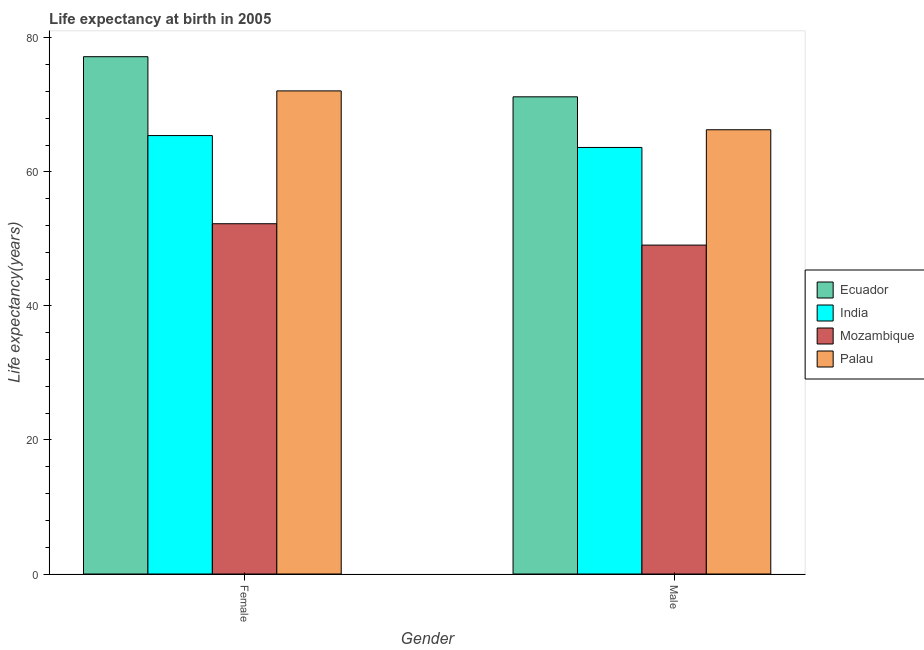Are the number of bars on each tick of the X-axis equal?
Make the answer very short. Yes. How many bars are there on the 2nd tick from the left?
Your answer should be very brief. 4. How many bars are there on the 1st tick from the right?
Your response must be concise. 4. What is the life expectancy(female) in India?
Provide a short and direct response. 65.43. Across all countries, what is the maximum life expectancy(female)?
Ensure brevity in your answer.  77.2. Across all countries, what is the minimum life expectancy(female)?
Make the answer very short. 52.27. In which country was the life expectancy(male) maximum?
Your response must be concise. Ecuador. In which country was the life expectancy(male) minimum?
Your response must be concise. Mozambique. What is the total life expectancy(female) in the graph?
Your response must be concise. 267.01. What is the difference between the life expectancy(female) in Palau and that in Ecuador?
Offer a very short reply. -5.11. What is the difference between the life expectancy(female) in Mozambique and the life expectancy(male) in Ecuador?
Your answer should be very brief. -18.94. What is the average life expectancy(male) per country?
Keep it short and to the point. 62.57. What is the difference between the life expectancy(female) and life expectancy(male) in Ecuador?
Your answer should be compact. 5.99. In how many countries, is the life expectancy(male) greater than 28 years?
Ensure brevity in your answer.  4. What is the ratio of the life expectancy(female) in Ecuador to that in Palau?
Ensure brevity in your answer.  1.07. Is the life expectancy(female) in Palau less than that in Ecuador?
Offer a very short reply. Yes. In how many countries, is the life expectancy(male) greater than the average life expectancy(male) taken over all countries?
Provide a succinct answer. 3. What does the 3rd bar from the left in Male represents?
Give a very brief answer. Mozambique. What does the 2nd bar from the right in Male represents?
Make the answer very short. Mozambique. How many bars are there?
Provide a succinct answer. 8. Are the values on the major ticks of Y-axis written in scientific E-notation?
Give a very brief answer. No. Does the graph contain grids?
Give a very brief answer. No. Where does the legend appear in the graph?
Your answer should be very brief. Center right. How are the legend labels stacked?
Give a very brief answer. Vertical. What is the title of the graph?
Your answer should be very brief. Life expectancy at birth in 2005. What is the label or title of the Y-axis?
Make the answer very short. Life expectancy(years). What is the Life expectancy(years) in Ecuador in Female?
Keep it short and to the point. 77.2. What is the Life expectancy(years) in India in Female?
Offer a very short reply. 65.43. What is the Life expectancy(years) of Mozambique in Female?
Your answer should be very brief. 52.27. What is the Life expectancy(years) of Palau in Female?
Your answer should be compact. 72.1. What is the Life expectancy(years) in Ecuador in Male?
Offer a terse response. 71.22. What is the Life expectancy(years) of India in Male?
Your response must be concise. 63.66. What is the Life expectancy(years) of Mozambique in Male?
Keep it short and to the point. 49.09. What is the Life expectancy(years) in Palau in Male?
Offer a terse response. 66.3. Across all Gender, what is the maximum Life expectancy(years) of Ecuador?
Offer a terse response. 77.2. Across all Gender, what is the maximum Life expectancy(years) in India?
Offer a very short reply. 65.43. Across all Gender, what is the maximum Life expectancy(years) of Mozambique?
Offer a very short reply. 52.27. Across all Gender, what is the maximum Life expectancy(years) of Palau?
Provide a succinct answer. 72.1. Across all Gender, what is the minimum Life expectancy(years) in Ecuador?
Give a very brief answer. 71.22. Across all Gender, what is the minimum Life expectancy(years) in India?
Ensure brevity in your answer.  63.66. Across all Gender, what is the minimum Life expectancy(years) of Mozambique?
Your response must be concise. 49.09. Across all Gender, what is the minimum Life expectancy(years) in Palau?
Provide a short and direct response. 66.3. What is the total Life expectancy(years) in Ecuador in the graph?
Keep it short and to the point. 148.42. What is the total Life expectancy(years) in India in the graph?
Offer a terse response. 129.09. What is the total Life expectancy(years) in Mozambique in the graph?
Give a very brief answer. 101.36. What is the total Life expectancy(years) in Palau in the graph?
Make the answer very short. 138.4. What is the difference between the Life expectancy(years) in Ecuador in Female and that in Male?
Offer a very short reply. 5.99. What is the difference between the Life expectancy(years) in India in Female and that in Male?
Provide a succinct answer. 1.77. What is the difference between the Life expectancy(years) of Mozambique in Female and that in Male?
Your answer should be very brief. 3.19. What is the difference between the Life expectancy(years) of Palau in Female and that in Male?
Your response must be concise. 5.8. What is the difference between the Life expectancy(years) of Ecuador in Female and the Life expectancy(years) of India in Male?
Give a very brief answer. 13.55. What is the difference between the Life expectancy(years) in Ecuador in Female and the Life expectancy(years) in Mozambique in Male?
Your answer should be very brief. 28.12. What is the difference between the Life expectancy(years) in Ecuador in Female and the Life expectancy(years) in Palau in Male?
Ensure brevity in your answer.  10.9. What is the difference between the Life expectancy(years) in India in Female and the Life expectancy(years) in Mozambique in Male?
Give a very brief answer. 16.35. What is the difference between the Life expectancy(years) of India in Female and the Life expectancy(years) of Palau in Male?
Ensure brevity in your answer.  -0.87. What is the difference between the Life expectancy(years) in Mozambique in Female and the Life expectancy(years) in Palau in Male?
Offer a terse response. -14.03. What is the average Life expectancy(years) of Ecuador per Gender?
Make the answer very short. 74.21. What is the average Life expectancy(years) of India per Gender?
Provide a succinct answer. 64.55. What is the average Life expectancy(years) of Mozambique per Gender?
Provide a succinct answer. 50.68. What is the average Life expectancy(years) of Palau per Gender?
Make the answer very short. 69.2. What is the difference between the Life expectancy(years) of Ecuador and Life expectancy(years) of India in Female?
Provide a succinct answer. 11.77. What is the difference between the Life expectancy(years) of Ecuador and Life expectancy(years) of Mozambique in Female?
Your answer should be compact. 24.93. What is the difference between the Life expectancy(years) of Ecuador and Life expectancy(years) of Palau in Female?
Offer a terse response. 5.11. What is the difference between the Life expectancy(years) in India and Life expectancy(years) in Mozambique in Female?
Your answer should be very brief. 13.16. What is the difference between the Life expectancy(years) in India and Life expectancy(years) in Palau in Female?
Your answer should be compact. -6.67. What is the difference between the Life expectancy(years) in Mozambique and Life expectancy(years) in Palau in Female?
Your answer should be very brief. -19.82. What is the difference between the Life expectancy(years) of Ecuador and Life expectancy(years) of India in Male?
Your response must be concise. 7.56. What is the difference between the Life expectancy(years) in Ecuador and Life expectancy(years) in Mozambique in Male?
Make the answer very short. 22.13. What is the difference between the Life expectancy(years) in Ecuador and Life expectancy(years) in Palau in Male?
Ensure brevity in your answer.  4.92. What is the difference between the Life expectancy(years) in India and Life expectancy(years) in Mozambique in Male?
Make the answer very short. 14.57. What is the difference between the Life expectancy(years) in India and Life expectancy(years) in Palau in Male?
Provide a succinct answer. -2.64. What is the difference between the Life expectancy(years) of Mozambique and Life expectancy(years) of Palau in Male?
Offer a very short reply. -17.21. What is the ratio of the Life expectancy(years) in Ecuador in Female to that in Male?
Give a very brief answer. 1.08. What is the ratio of the Life expectancy(years) of India in Female to that in Male?
Provide a succinct answer. 1.03. What is the ratio of the Life expectancy(years) in Mozambique in Female to that in Male?
Keep it short and to the point. 1.06. What is the ratio of the Life expectancy(years) in Palau in Female to that in Male?
Make the answer very short. 1.09. What is the difference between the highest and the second highest Life expectancy(years) in Ecuador?
Make the answer very short. 5.99. What is the difference between the highest and the second highest Life expectancy(years) of India?
Your answer should be very brief. 1.77. What is the difference between the highest and the second highest Life expectancy(years) of Mozambique?
Your response must be concise. 3.19. What is the difference between the highest and the lowest Life expectancy(years) in Ecuador?
Provide a succinct answer. 5.99. What is the difference between the highest and the lowest Life expectancy(years) of India?
Give a very brief answer. 1.77. What is the difference between the highest and the lowest Life expectancy(years) in Mozambique?
Provide a short and direct response. 3.19. What is the difference between the highest and the lowest Life expectancy(years) in Palau?
Provide a short and direct response. 5.8. 